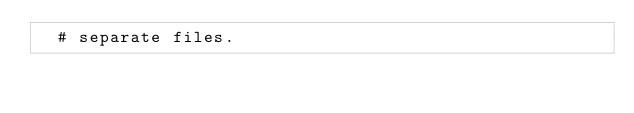Convert code to text. <code><loc_0><loc_0><loc_500><loc_500><_Bash_>  # separate files.</code> 